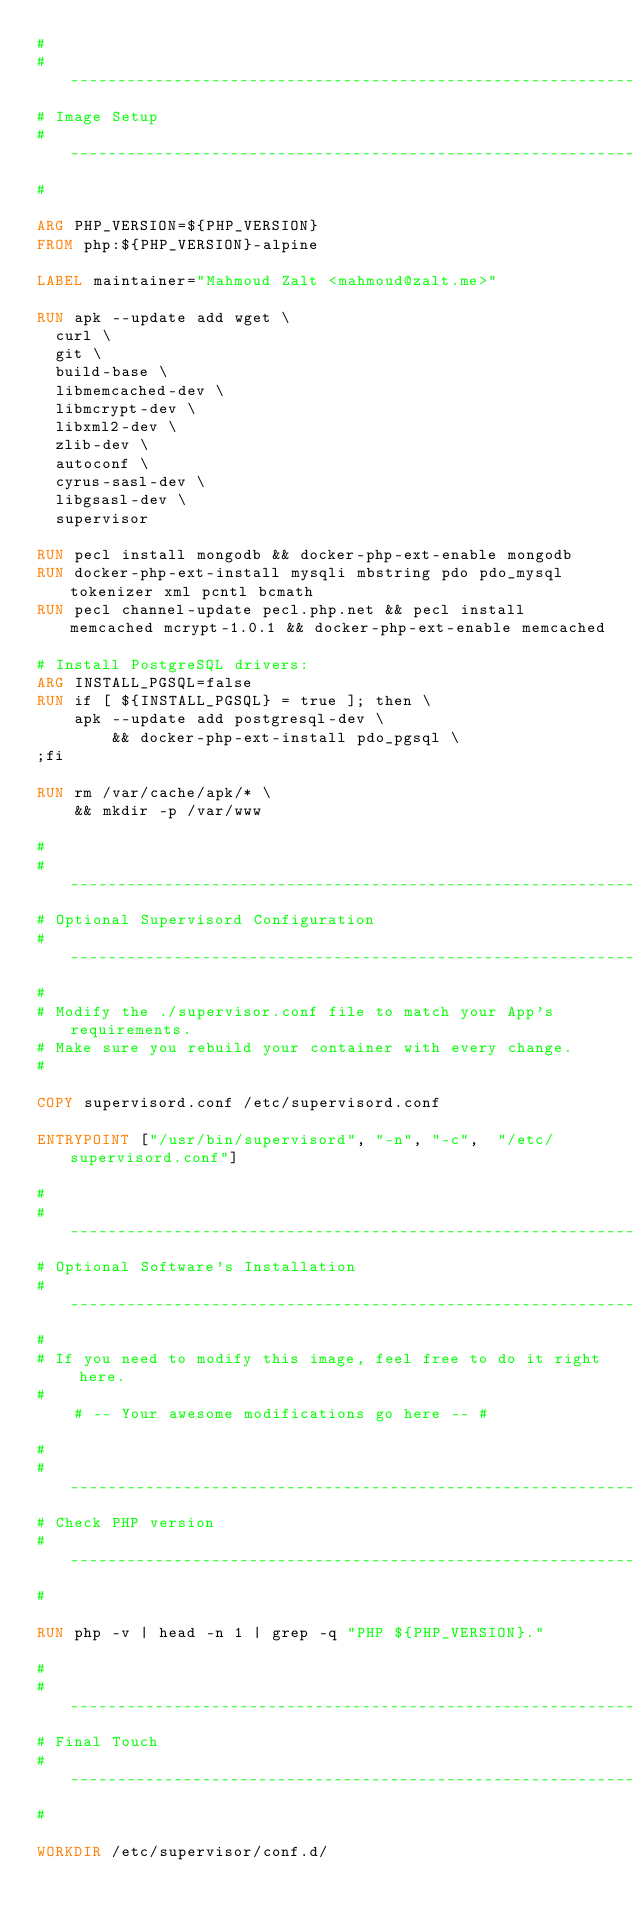Convert code to text. <code><loc_0><loc_0><loc_500><loc_500><_Dockerfile_>#
#--------------------------------------------------------------------------
# Image Setup
#--------------------------------------------------------------------------
#

ARG PHP_VERSION=${PHP_VERSION}
FROM php:${PHP_VERSION}-alpine

LABEL maintainer="Mahmoud Zalt <mahmoud@zalt.me>"

RUN apk --update add wget \
  curl \
  git \
  build-base \
  libmemcached-dev \
  libmcrypt-dev \
  libxml2-dev \
  zlib-dev \
  autoconf \
  cyrus-sasl-dev \
  libgsasl-dev \
  supervisor

RUN pecl install mongodb && docker-php-ext-enable mongodb
RUN docker-php-ext-install mysqli mbstring pdo pdo_mysql tokenizer xml pcntl bcmath
RUN pecl channel-update pecl.php.net && pecl install memcached mcrypt-1.0.1 && docker-php-ext-enable memcached

# Install PostgreSQL drivers:
ARG INSTALL_PGSQL=false
RUN if [ ${INSTALL_PGSQL} = true ]; then \
    apk --update add postgresql-dev \
        && docker-php-ext-install pdo_pgsql \
;fi

RUN rm /var/cache/apk/* \
    && mkdir -p /var/www

#
#--------------------------------------------------------------------------
# Optional Supervisord Configuration
#--------------------------------------------------------------------------
#
# Modify the ./supervisor.conf file to match your App's requirements.
# Make sure you rebuild your container with every change.
#

COPY supervisord.conf /etc/supervisord.conf

ENTRYPOINT ["/usr/bin/supervisord", "-n", "-c",  "/etc/supervisord.conf"]

#
#--------------------------------------------------------------------------
# Optional Software's Installation
#--------------------------------------------------------------------------
#
# If you need to modify this image, feel free to do it right here.
#
    # -- Your awesome modifications go here -- #

#
#--------------------------------------------------------------------------
# Check PHP version
#--------------------------------------------------------------------------
#

RUN php -v | head -n 1 | grep -q "PHP ${PHP_VERSION}."

#
#--------------------------------------------------------------------------
# Final Touch
#--------------------------------------------------------------------------
#

WORKDIR /etc/supervisor/conf.d/
</code> 